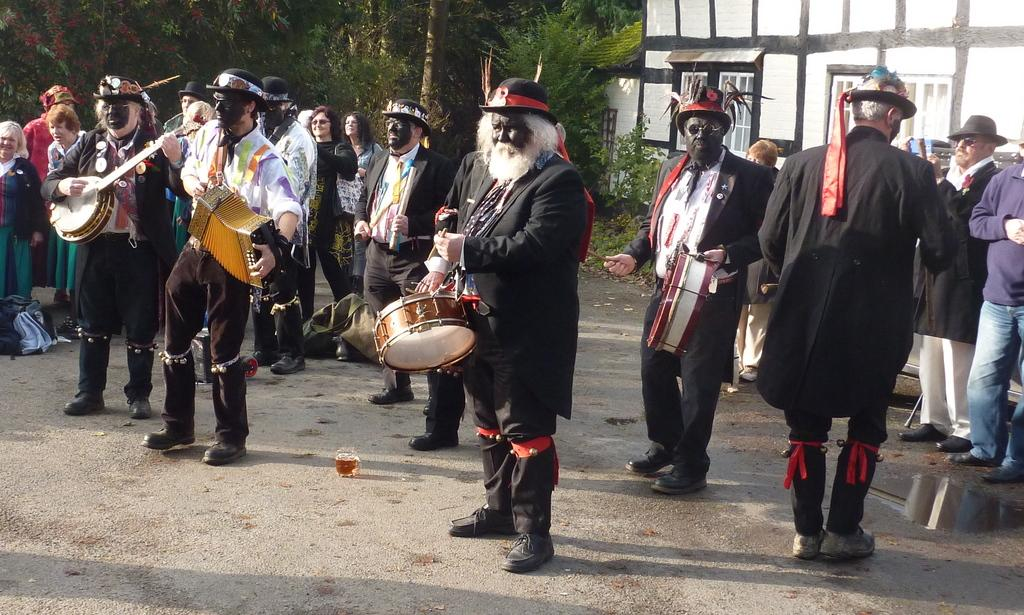How many people are in the image? There is a group of people in the image, but the exact number is not specified. What are the people doing in the image? Some people are playing musical instruments, while others are standing on the road. What can be seen in the background of the image? There is a building and trees in the background of the image. What type of hammer is being used to play the musical instruments in the image? There is no hammer present in the image, and the musical instruments are being played without any hammers. What form does the net take in the image? There is no net present in the image. 